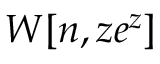<formula> <loc_0><loc_0><loc_500><loc_500>W [ n , z e ^ { z } ]</formula> 